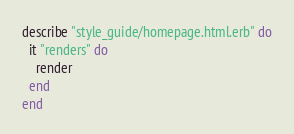<code> <loc_0><loc_0><loc_500><loc_500><_Ruby_>
describe "style_guide/homepage.html.erb" do
  it "renders" do
    render
  end
end
</code> 